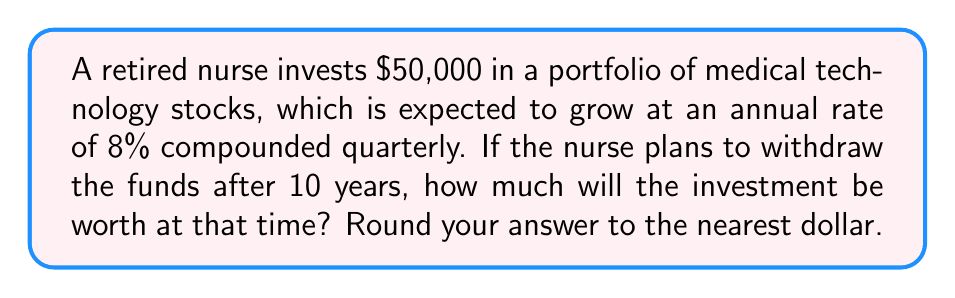Show me your answer to this math problem. To solve this problem, we'll use the compound interest formula:

$$A = P(1 + \frac{r}{n})^{nt}$$

Where:
$A$ = Final amount
$P$ = Principal (initial investment)
$r$ = Annual interest rate (as a decimal)
$n$ = Number of times interest is compounded per year
$t$ = Number of years

Given:
$P = \$50,000$
$r = 0.08$ (8% expressed as a decimal)
$n = 4$ (compounded quarterly)
$t = 10$ years

Let's substitute these values into the formula:

$$A = 50000(1 + \frac{0.08}{4})^{4 \times 10}$$

$$A = 50000(1 + 0.02)^{40}$$

$$A = 50000(1.02)^{40}$$

Using a calculator or computer to evaluate this expression:

$$A = 50000 \times 2.2080399...$$

$$A = 110401.99...$$

Rounding to the nearest dollar:

$$A = \$110,402$$
Answer: $110,402 